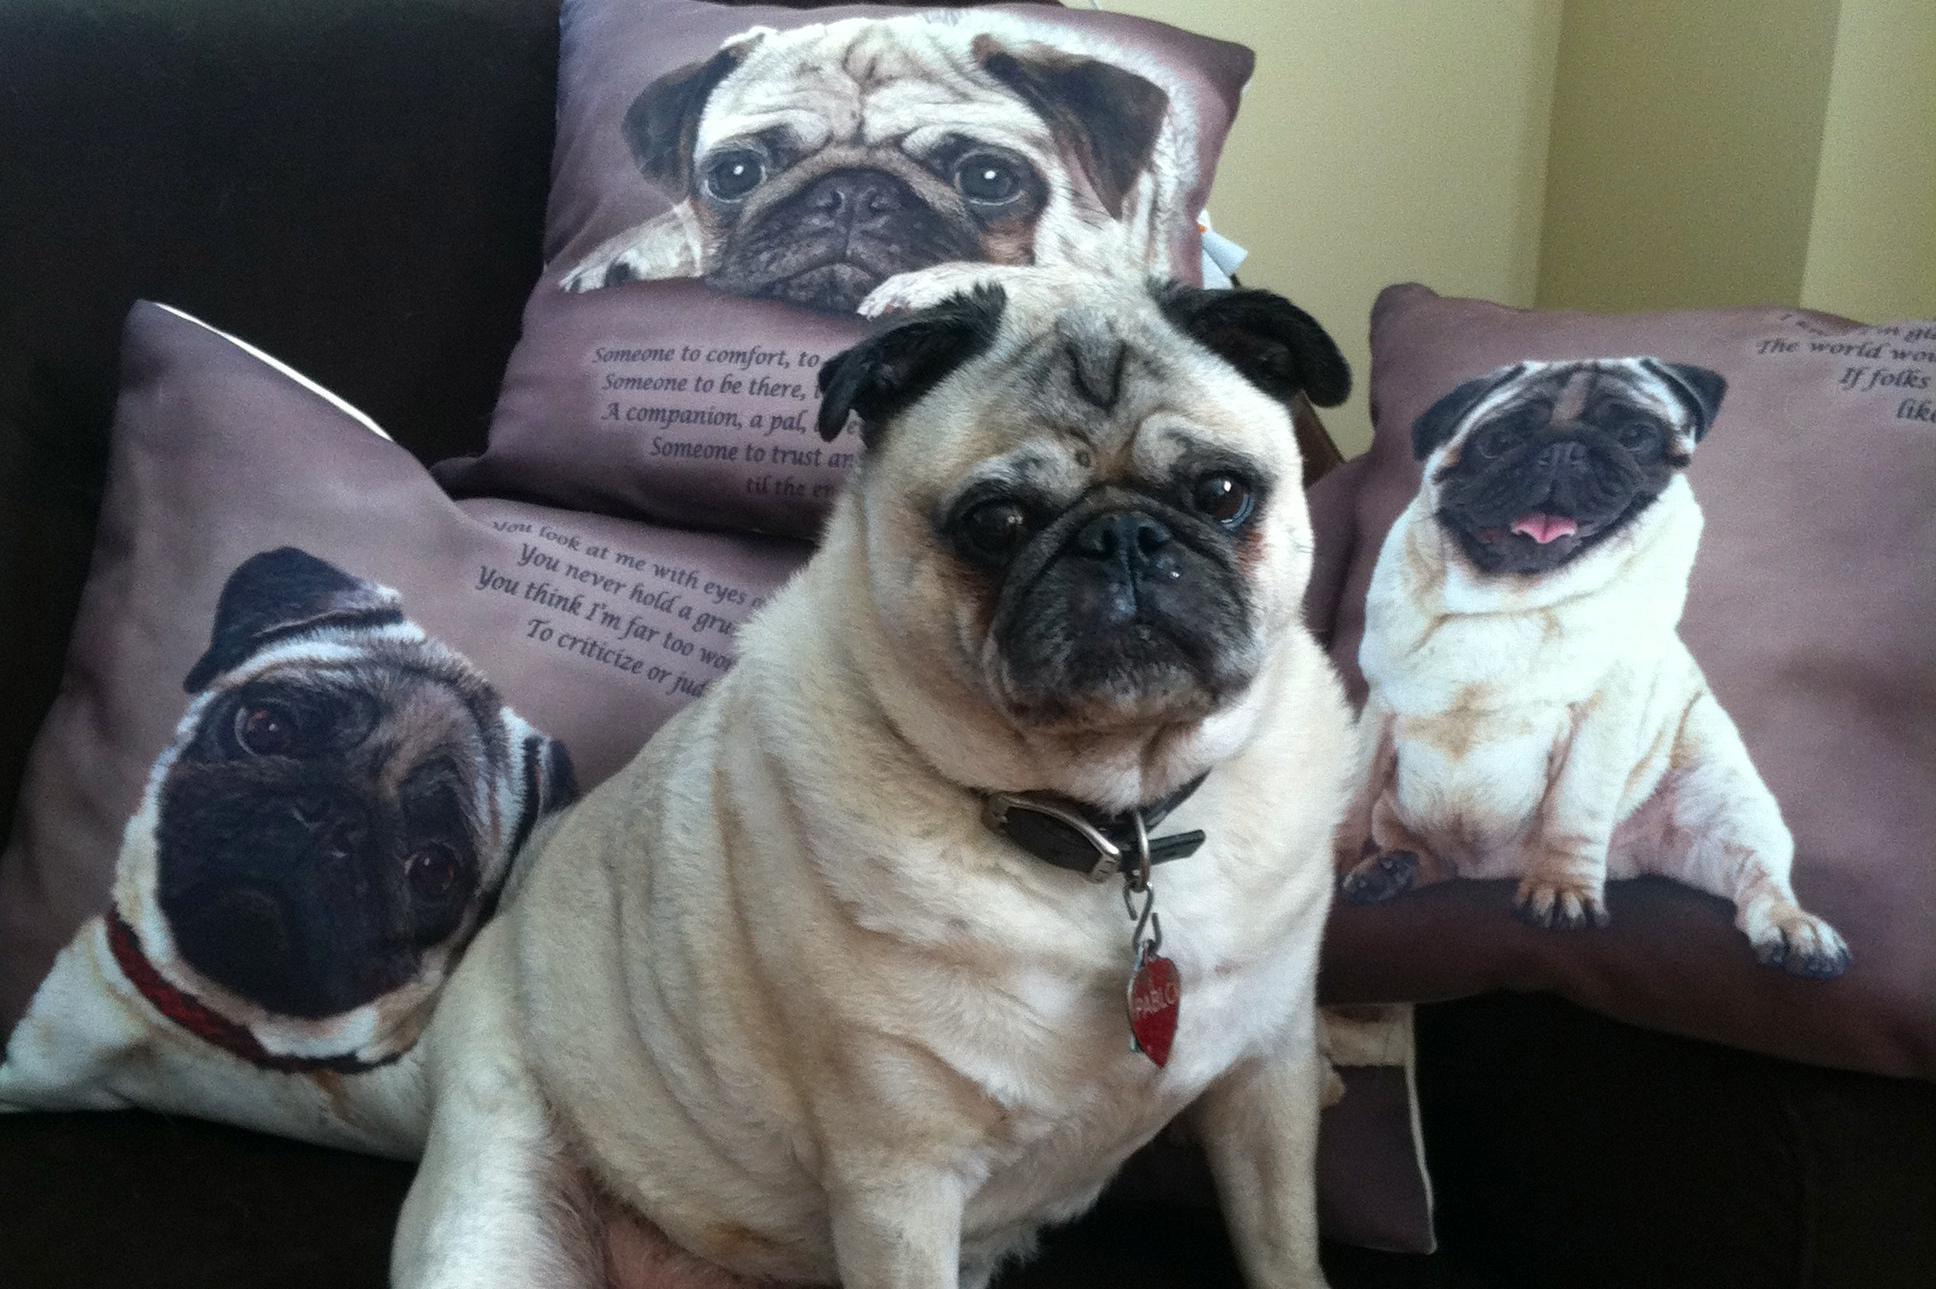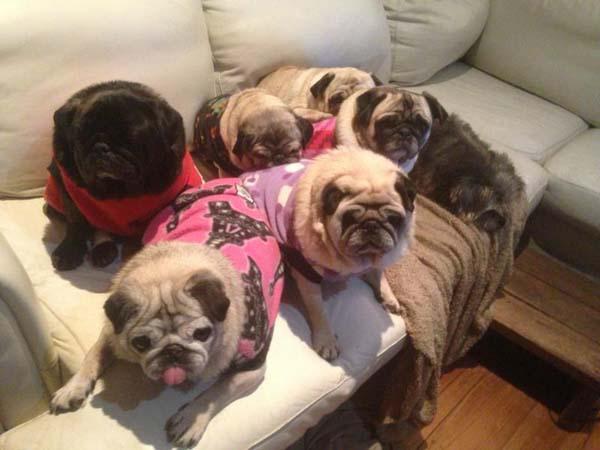The first image is the image on the left, the second image is the image on the right. Considering the images on both sides, is "An image contains at least three pug dogs dressed in garments other than dog collars." valid? Answer yes or no. Yes. The first image is the image on the left, the second image is the image on the right. For the images shown, is this caption "In one of the images, at least one of the dogs is entirely black." true? Answer yes or no. Yes. 